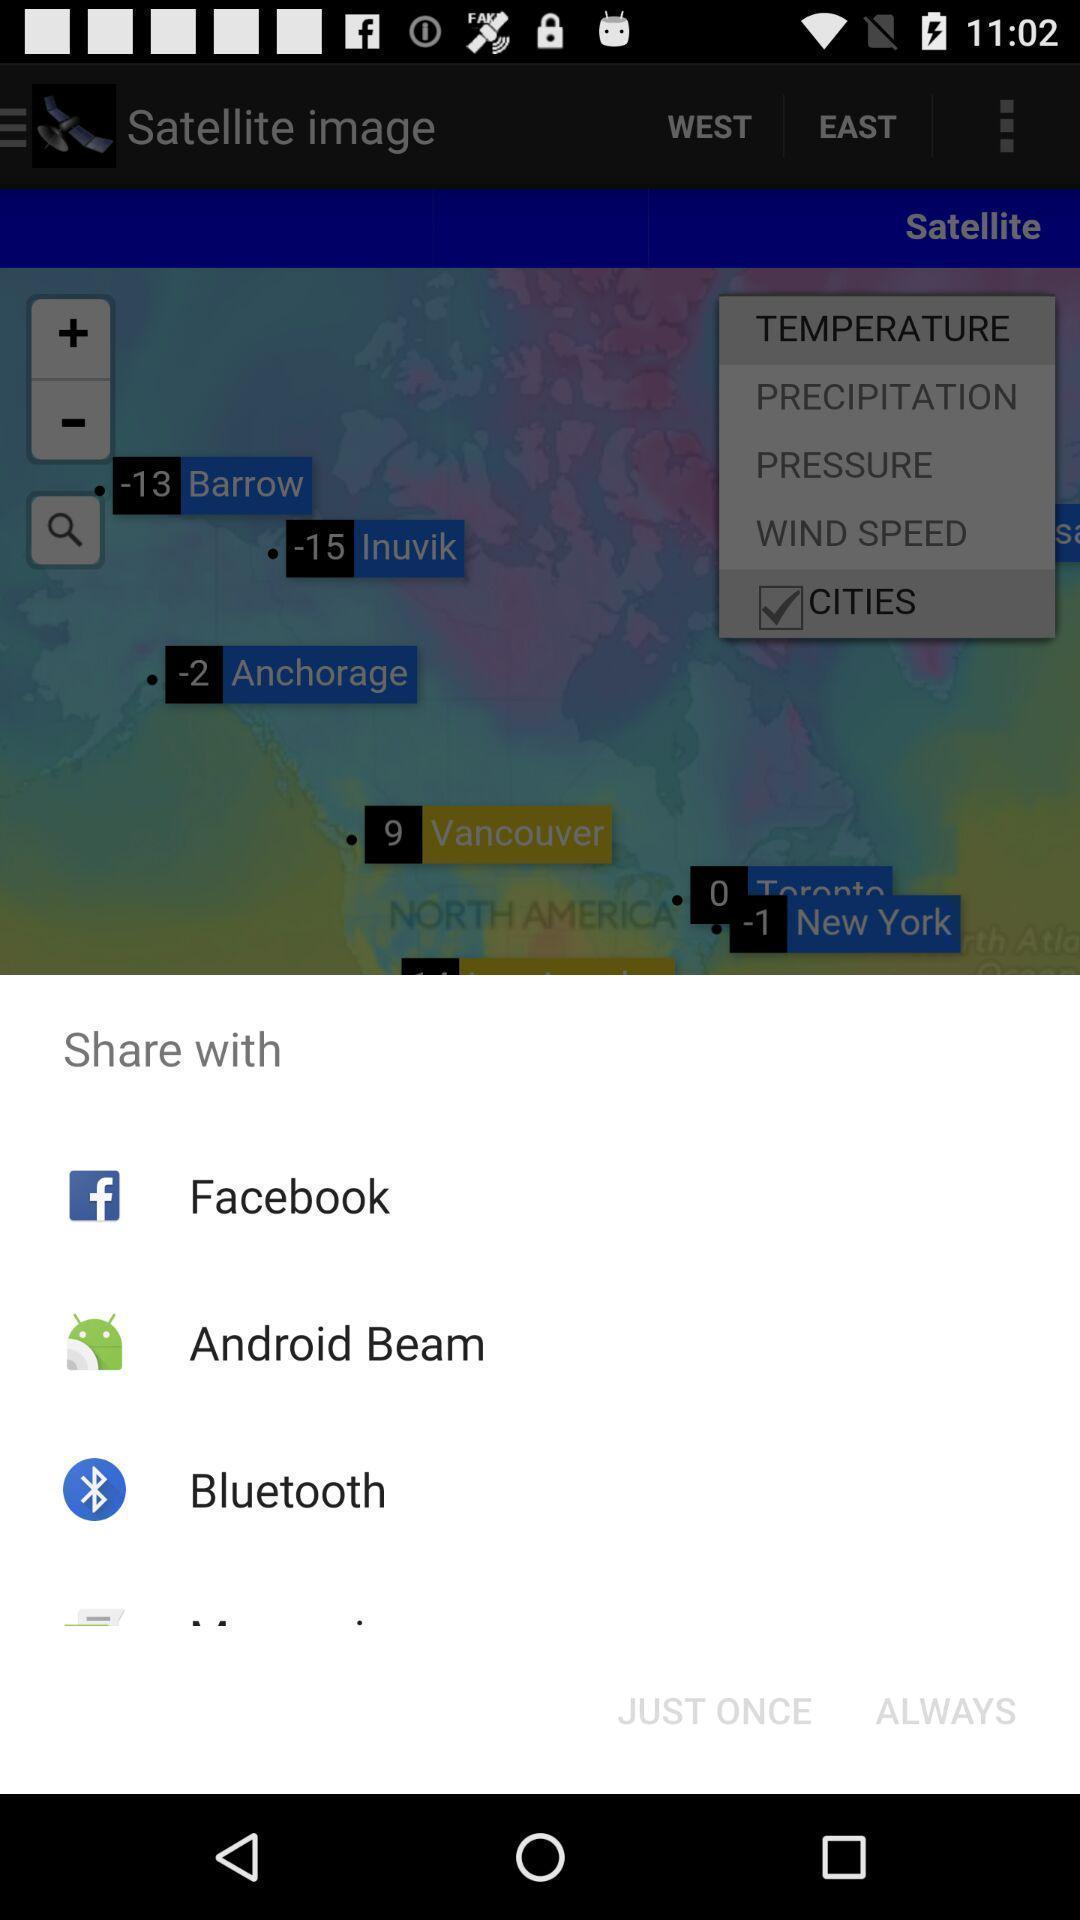Give me a narrative description of this picture. Pop-up showing various share options. 